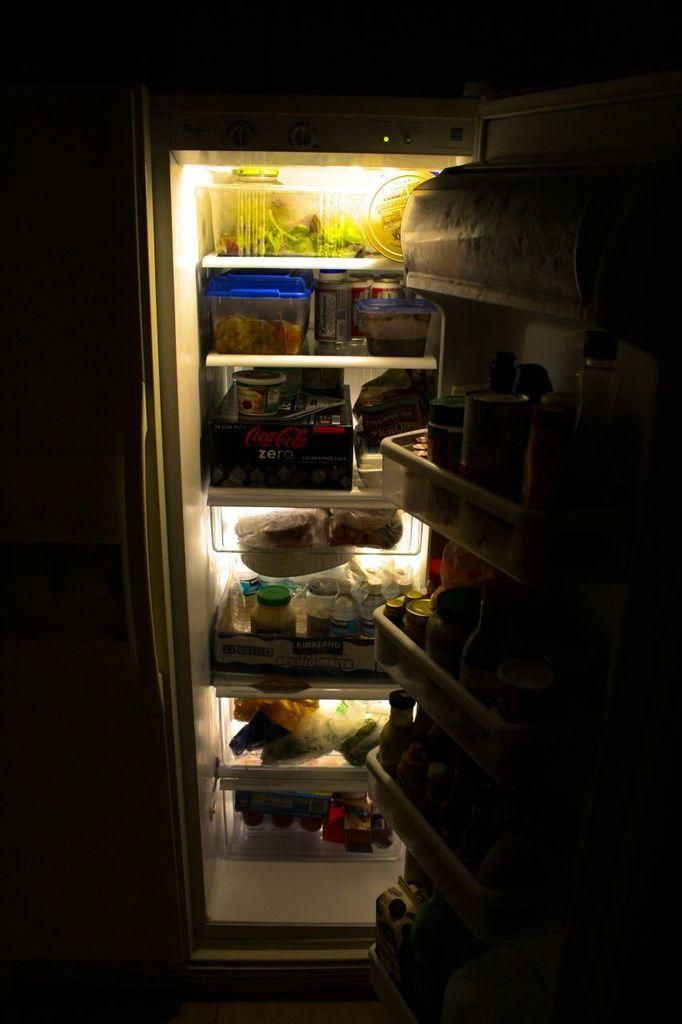What appliance is visible in the image? There is a refrigerator in the image. What can be found inside the refrigerator? There are bottles and other objects inside the refrigerator. Can you describe the background of the image? The background of the image is dark. We start by identifying the main subject in the image, which is the refrigerator. Then, we describe what is inside the refrigerator, as mentioned in the facts. Finally, we address the background of the image, which is also provided in the facts. We ensure that each question can be answered definitively with the information given. Absurd Question/Answer: What type of flock is flying over the refrigerator in the image? There is no flock present in the image. What type of flag is visible on the moon in the image? There is no flag or moon present in the image. 